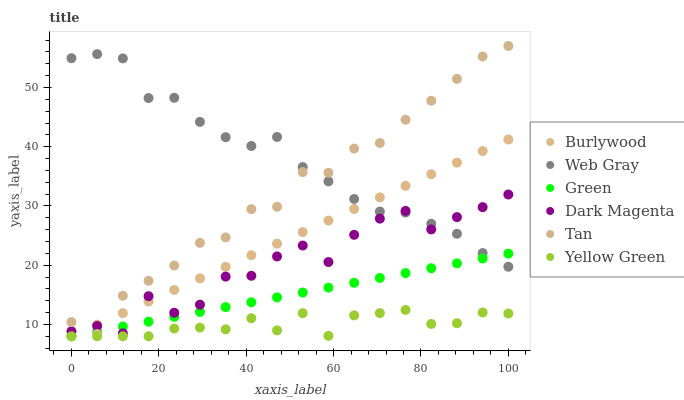Does Yellow Green have the minimum area under the curve?
Answer yes or no. Yes. Does Web Gray have the maximum area under the curve?
Answer yes or no. Yes. Does Dark Magenta have the minimum area under the curve?
Answer yes or no. No. Does Dark Magenta have the maximum area under the curve?
Answer yes or no. No. Is Burlywood the smoothest?
Answer yes or no. Yes. Is Dark Magenta the roughest?
Answer yes or no. Yes. Is Dark Magenta the smoothest?
Answer yes or no. No. Is Burlywood the roughest?
Answer yes or no. No. Does Burlywood have the lowest value?
Answer yes or no. Yes. Does Dark Magenta have the lowest value?
Answer yes or no. No. Does Tan have the highest value?
Answer yes or no. Yes. Does Dark Magenta have the highest value?
Answer yes or no. No. Is Yellow Green less than Dark Magenta?
Answer yes or no. Yes. Is Web Gray greater than Yellow Green?
Answer yes or no. Yes. Does Green intersect Web Gray?
Answer yes or no. Yes. Is Green less than Web Gray?
Answer yes or no. No. Is Green greater than Web Gray?
Answer yes or no. No. Does Yellow Green intersect Dark Magenta?
Answer yes or no. No. 